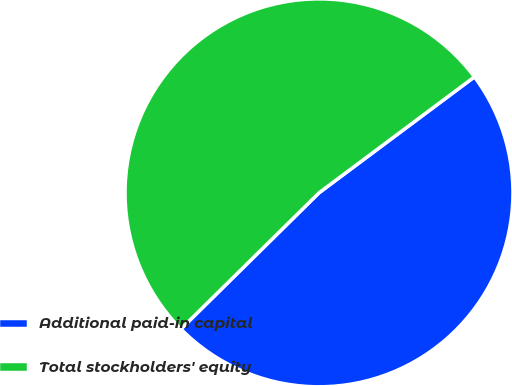Convert chart to OTSL. <chart><loc_0><loc_0><loc_500><loc_500><pie_chart><fcel>Additional paid-in capital<fcel>Total stockholders' equity<nl><fcel>47.81%<fcel>52.19%<nl></chart> 